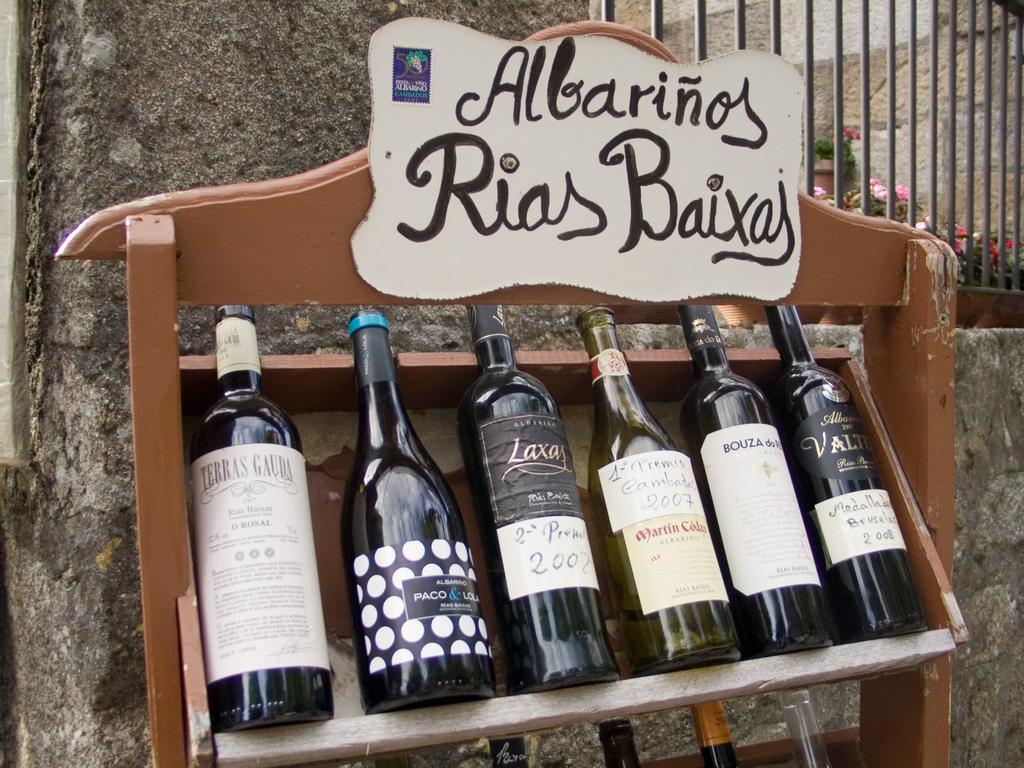What kind of alcohol is this on the shelf?
Your response must be concise. Wine. What year is on the label on the far right?
Make the answer very short. 2008. 